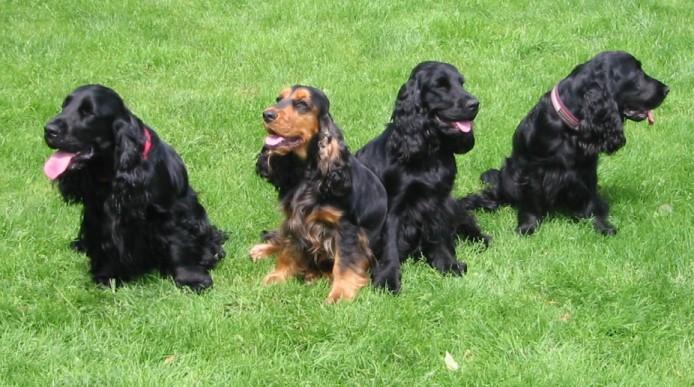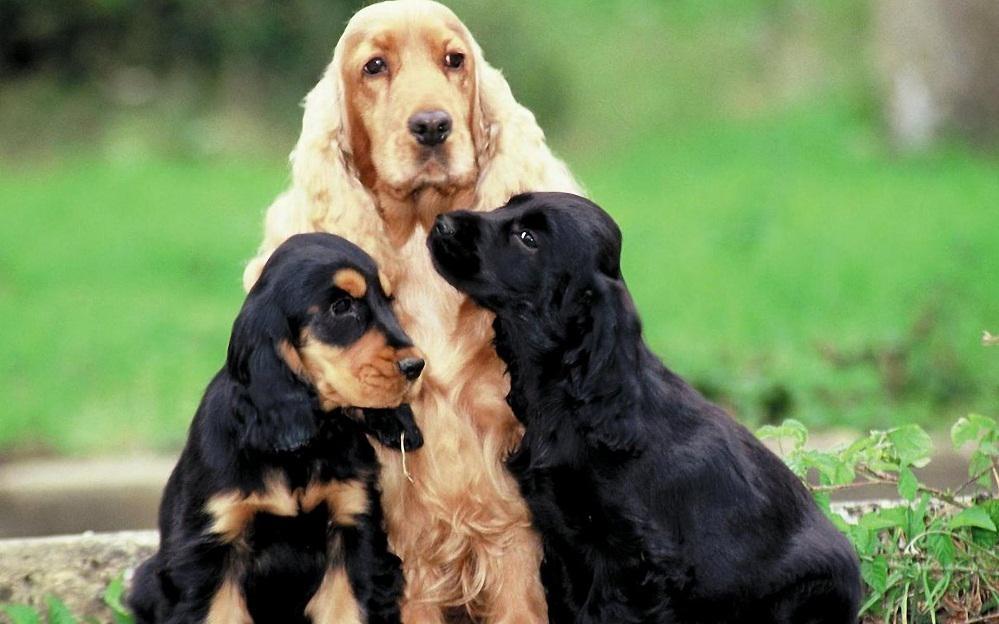The first image is the image on the left, the second image is the image on the right. Evaluate the accuracy of this statement regarding the images: "A black-and-tan dog sits upright on the left of a golden haired dog that also sits upright.". Is it true? Answer yes or no. Yes. The first image is the image on the left, the second image is the image on the right. Considering the images on both sides, is "The right image contains at least three dogs." valid? Answer yes or no. Yes. 